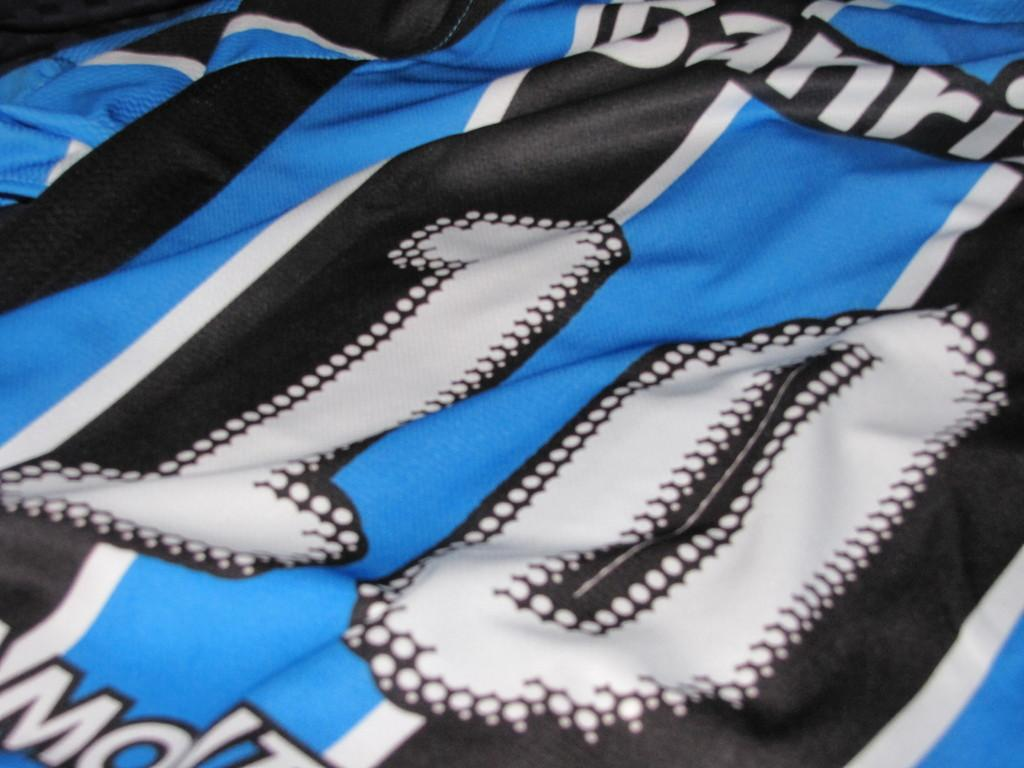<image>
Create a compact narrative representing the image presented. A number 10 blue and black Jersey of an unknown team. 